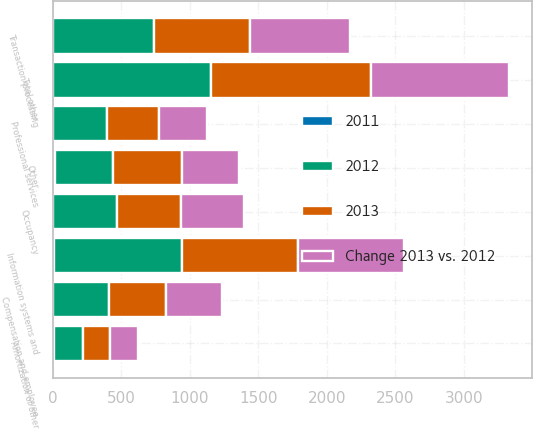Convert chart to OTSL. <chart><loc_0><loc_0><loc_500><loc_500><stacked_bar_chart><ecel><fcel>Compensation and employee<fcel>Information systems and<fcel>Transaction processing<fcel>Occupancy<fcel>Professional services<fcel>Amortization of other<fcel>Other<fcel>Total other<nl><fcel>2012<fcel>412<fcel>935<fcel>733<fcel>467<fcel>392<fcel>214<fcel>423<fcel>1153<nl><fcel>2013<fcel>412<fcel>844<fcel>702<fcel>470<fcel>381<fcel>198<fcel>506<fcel>1170<nl><fcel>Change 2013 vs. 2012<fcel>412<fcel>776<fcel>732<fcel>455<fcel>347<fcel>200<fcel>412<fcel>1006<nl><fcel>2011<fcel>1<fcel>11<fcel>4<fcel>1<fcel>3<fcel>8<fcel>16<fcel>1<nl></chart> 